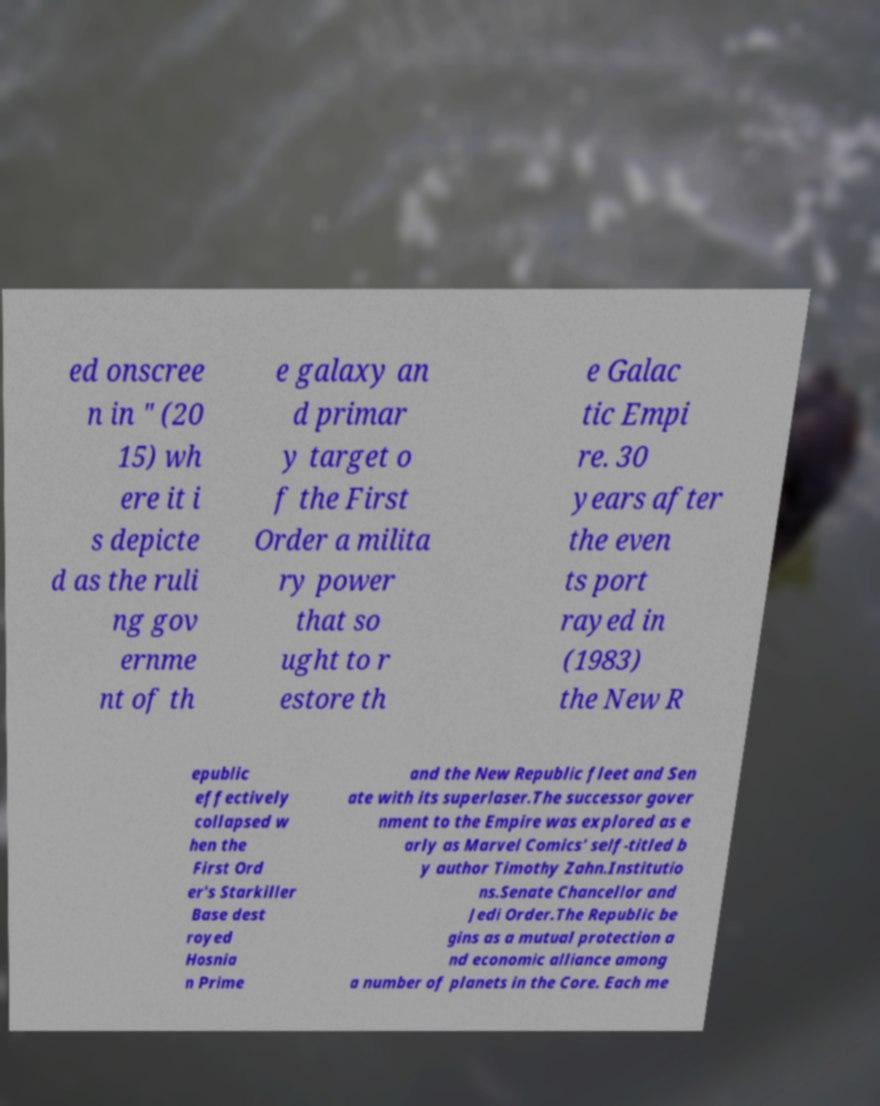Please identify and transcribe the text found in this image. ed onscree n in " (20 15) wh ere it i s depicte d as the ruli ng gov ernme nt of th e galaxy an d primar y target o f the First Order a milita ry power that so ught to r estore th e Galac tic Empi re. 30 years after the even ts port rayed in (1983) the New R epublic effectively collapsed w hen the First Ord er's Starkiller Base dest royed Hosnia n Prime and the New Republic fleet and Sen ate with its superlaser.The successor gover nment to the Empire was explored as e arly as Marvel Comics' self-titled b y author Timothy Zahn.Institutio ns.Senate Chancellor and Jedi Order.The Republic be gins as a mutual protection a nd economic alliance among a number of planets in the Core. Each me 